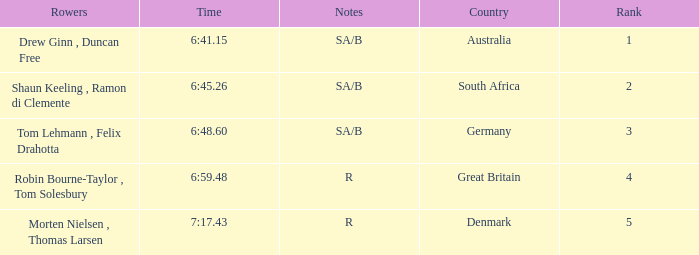What was the time for the rowers representing great britain? 6:59.48. 